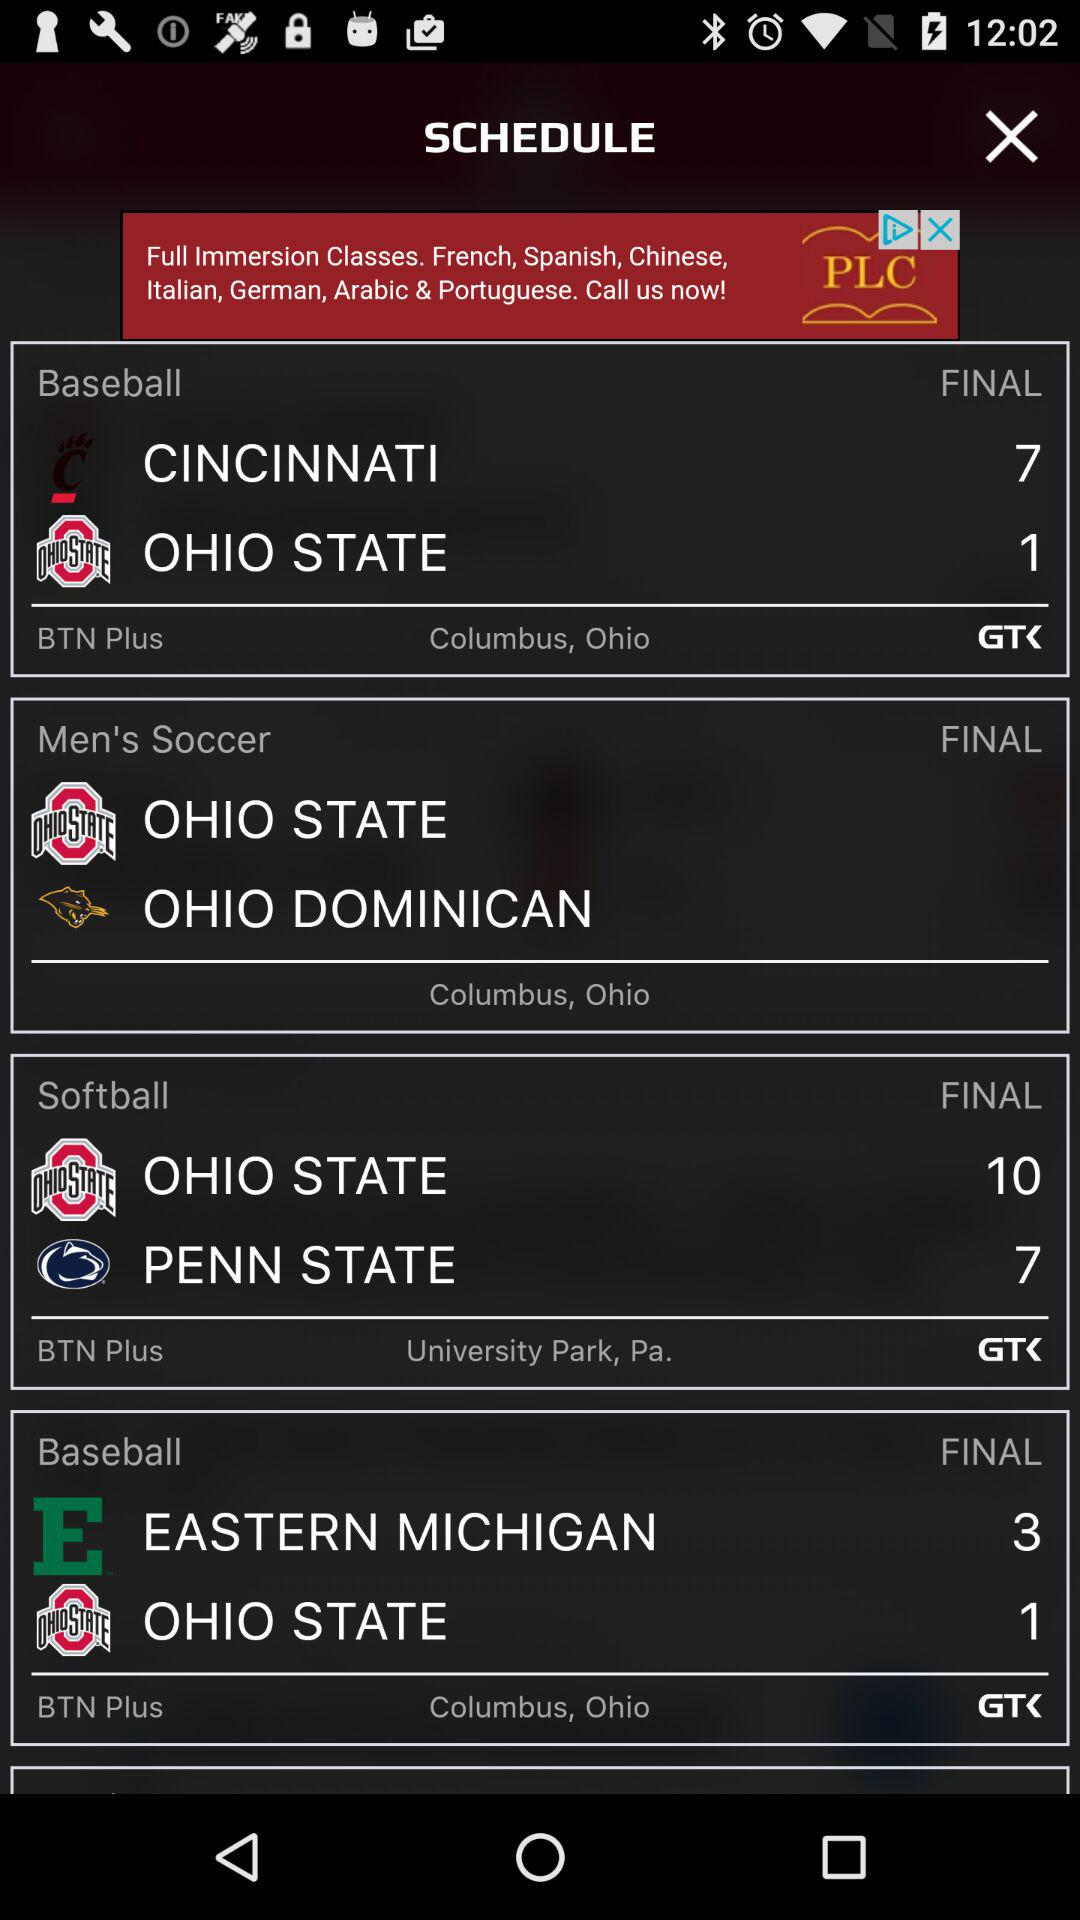What are the final scores of the softball teams? The final scores of "OHIO STATE" and "PENN STATE" are 10 and 7, respectively. 